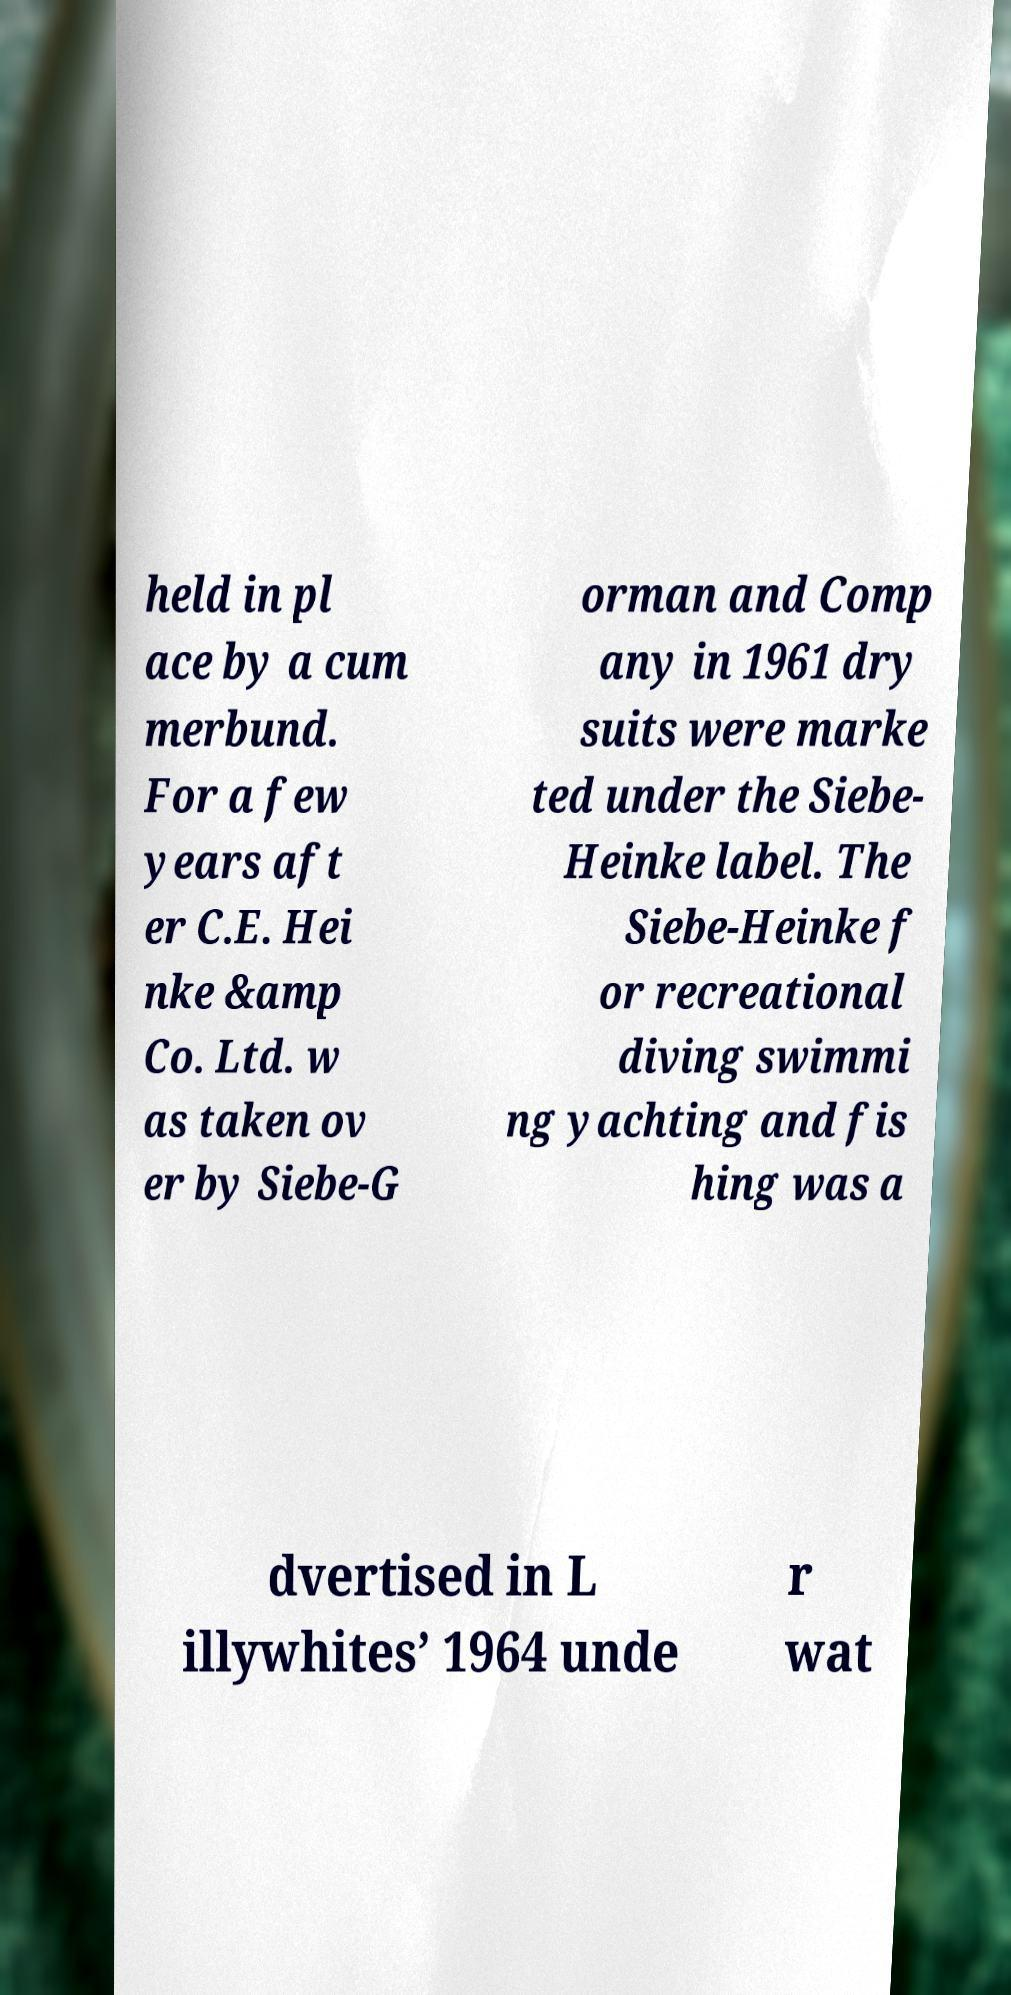Please identify and transcribe the text found in this image. held in pl ace by a cum merbund. For a few years aft er C.E. Hei nke &amp Co. Ltd. w as taken ov er by Siebe-G orman and Comp any in 1961 dry suits were marke ted under the Siebe- Heinke label. The Siebe-Heinke f or recreational diving swimmi ng yachting and fis hing was a dvertised in L illywhites’ 1964 unde r wat 